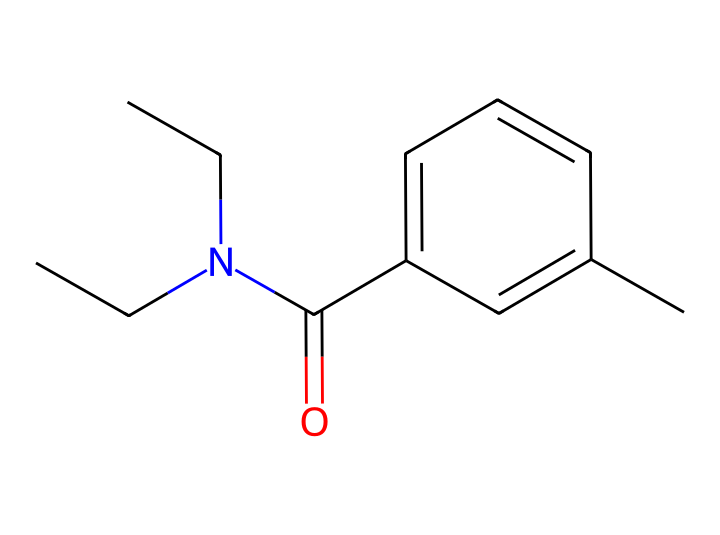What is the name of this chemical? The chemical structure corresponds to the common insect repellent known as DEET. The SMILES notation provided can be linked to its commonly recognized chemical name.
Answer: DEET How many carbon atoms are present in this molecule? To determine the number of carbon atoms, count each "C" in the SMILES representation. The structure shows 11 carbon atoms overall.
Answer: 11 What type of functional group is present in DEET? By examining the structure, we see that the carbonyl group (C=O) is indicative of an amide functional group in this compound. This establishes DEET's classification in organic chemistry.
Answer: amide What is the total number of nitrogen atoms in this molecule? Looking at the SMILES, there is one nitrogen atom (N) present. Therefore, the answer reflects the total count of nitrogen in the molecular structure.
Answer: 1 Does this chemical have any aromatic rings? The structure shows a cyclic arrangement with alternating double bonds, which is characteristic of aromatic rings. Therefore, we conclude that there is indeed an aromatic ring present.
Answer: yes What is the primary purpose of DEET in sports and outdoor activities? The primary use of DEET is to repel insects, which helps to prevent bites while people are participating in outdoor activities, including sports. Hence, its function is to offer protection.
Answer: repellent 